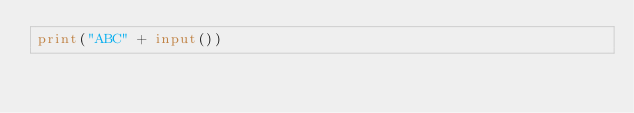Convert code to text. <code><loc_0><loc_0><loc_500><loc_500><_Python_>print("ABC" + input())
</code> 